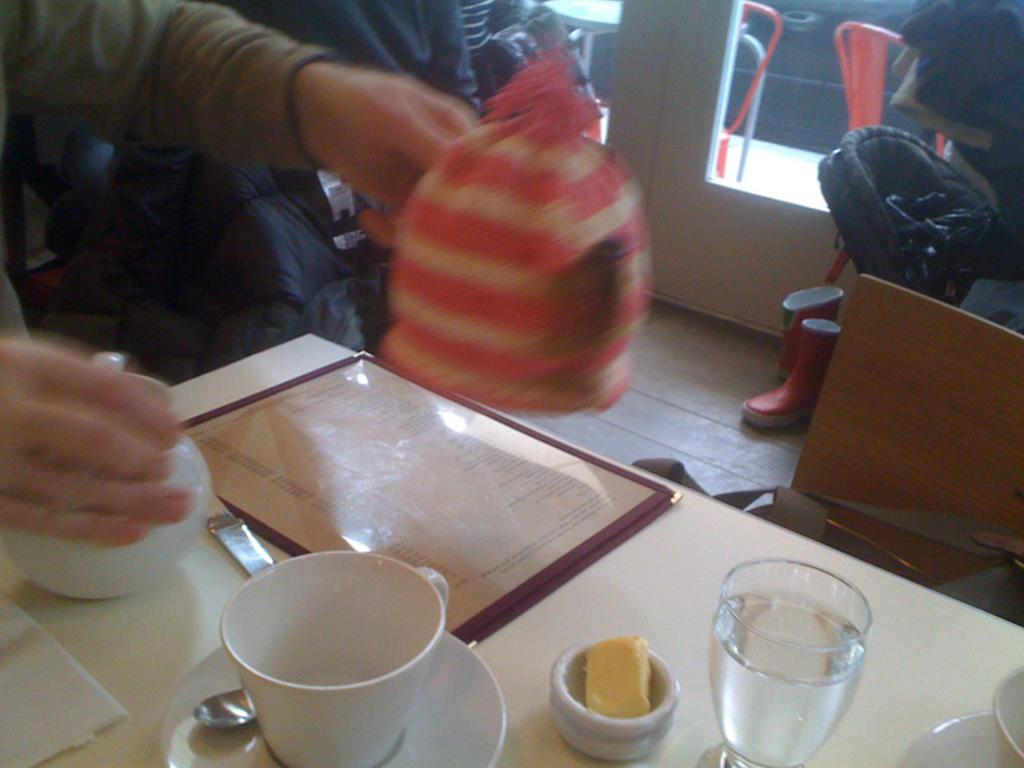What is present on the table in the image? There is a cup, a saucer, a spoon, a glass with water, and a teapot on the table in the image. Can you describe the table setting in the image? The table setting includes a cup, a saucer, a spoon, a glass with water, and a teapot. What can be seen in the background of the image? There are two persons, a window, shoes, and chairs in the background of the image. What type of office furniture is present in the image? There is no office furniture present in the image. What kind of dress is the person in the background wearing? There is no person wearing a dress in the image; the two persons in the background are not visible in detail. 